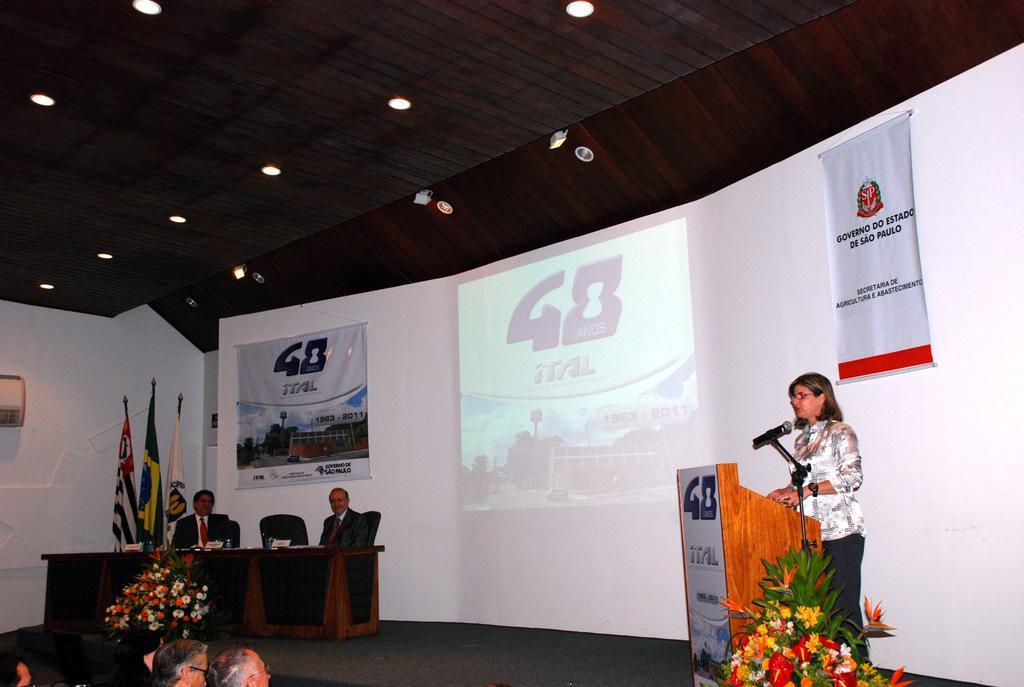Describe this image in one or two sentences. In this image we can a woman standing beside a speaker stand. We can also see a mic with a stand and some flower bouquets on the stage. On the left side we can see some people sitting and a table containing some objects on it. We can also see the flags. On the backside we can see some banners, a device and a display screen on a wall and some ceiling lights to a roof. 